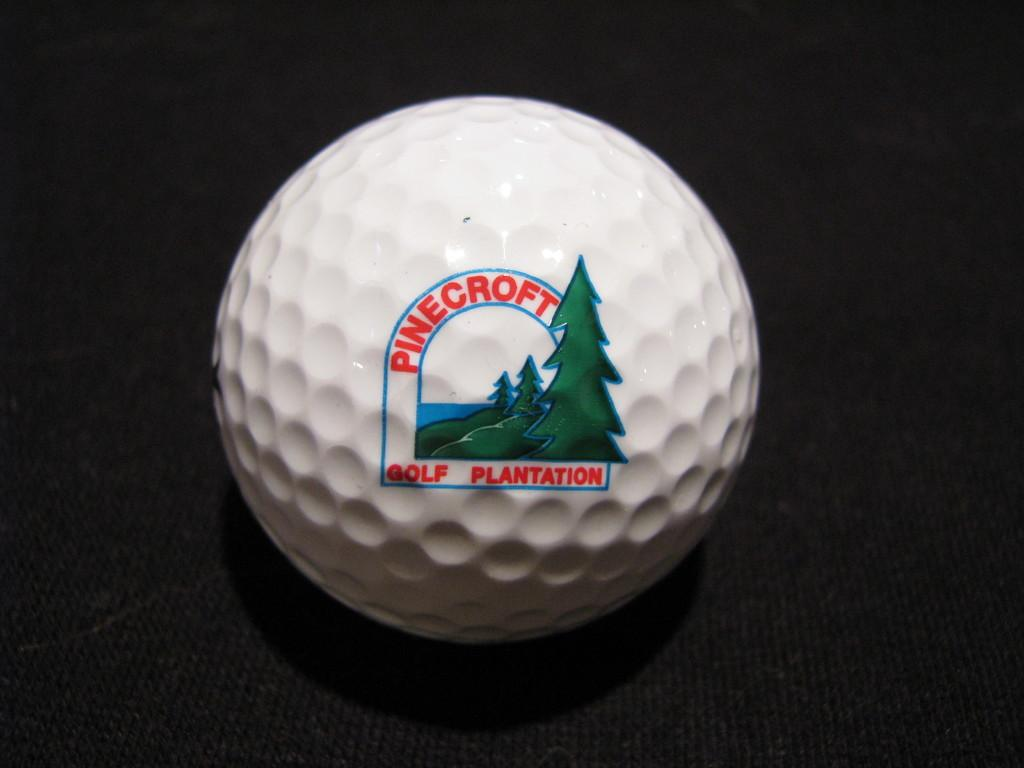<image>
Share a concise interpretation of the image provided. The white golf ball is from Pinecroft Golf Plantation. 